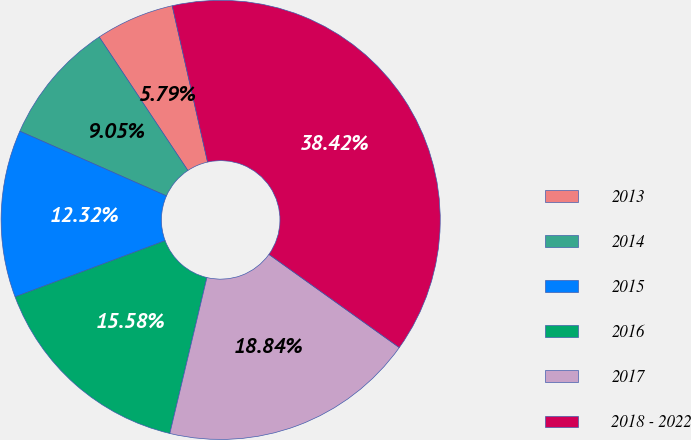<chart> <loc_0><loc_0><loc_500><loc_500><pie_chart><fcel>2013<fcel>2014<fcel>2015<fcel>2016<fcel>2017<fcel>2018 - 2022<nl><fcel>5.79%<fcel>9.05%<fcel>12.32%<fcel>15.58%<fcel>18.84%<fcel>38.42%<nl></chart> 